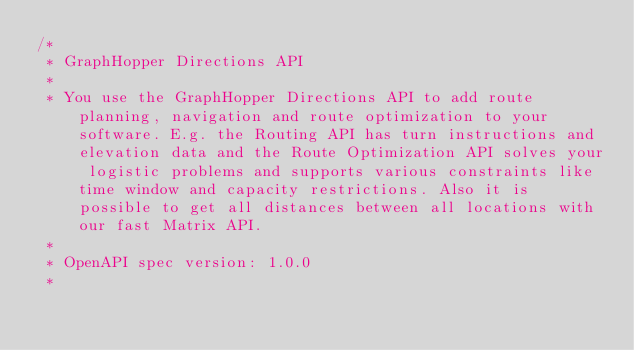<code> <loc_0><loc_0><loc_500><loc_500><_Rust_>/* 
 * GraphHopper Directions API
 *
 * You use the GraphHopper Directions API to add route planning, navigation and route optimization to your software. E.g. the Routing API has turn instructions and elevation data and the Route Optimization API solves your logistic problems and supports various constraints like time window and capacity restrictions. Also it is possible to get all distances between all locations with our fast Matrix API.
 *
 * OpenAPI spec version: 1.0.0
 * </code> 